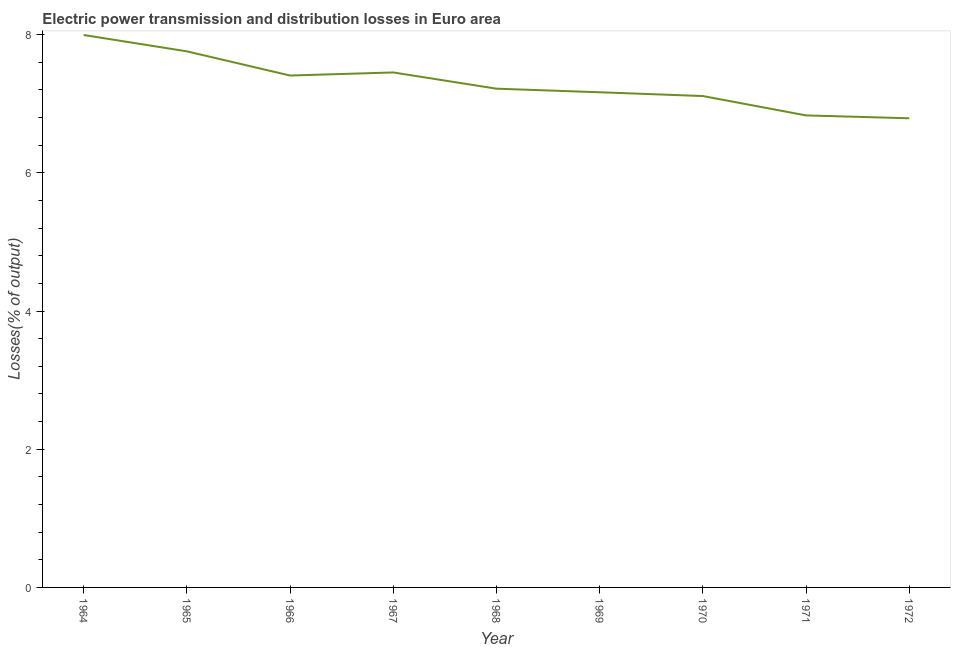What is the electric power transmission and distribution losses in 1965?
Make the answer very short. 7.76. Across all years, what is the maximum electric power transmission and distribution losses?
Offer a terse response. 8. Across all years, what is the minimum electric power transmission and distribution losses?
Give a very brief answer. 6.79. In which year was the electric power transmission and distribution losses maximum?
Ensure brevity in your answer.  1964. In which year was the electric power transmission and distribution losses minimum?
Your answer should be very brief. 1972. What is the sum of the electric power transmission and distribution losses?
Ensure brevity in your answer.  65.74. What is the difference between the electric power transmission and distribution losses in 1968 and 1971?
Give a very brief answer. 0.39. What is the average electric power transmission and distribution losses per year?
Provide a short and direct response. 7.3. What is the median electric power transmission and distribution losses?
Ensure brevity in your answer.  7.22. In how many years, is the electric power transmission and distribution losses greater than 2.8 %?
Offer a terse response. 9. Do a majority of the years between 1970 and 1965 (inclusive) have electric power transmission and distribution losses greater than 3.2 %?
Offer a very short reply. Yes. What is the ratio of the electric power transmission and distribution losses in 1966 to that in 1970?
Keep it short and to the point. 1.04. Is the electric power transmission and distribution losses in 1966 less than that in 1967?
Offer a very short reply. Yes. What is the difference between the highest and the second highest electric power transmission and distribution losses?
Provide a short and direct response. 0.24. What is the difference between the highest and the lowest electric power transmission and distribution losses?
Provide a short and direct response. 1.21. Does the electric power transmission and distribution losses monotonically increase over the years?
Your answer should be very brief. No. How many years are there in the graph?
Make the answer very short. 9. What is the difference between two consecutive major ticks on the Y-axis?
Provide a succinct answer. 2. Are the values on the major ticks of Y-axis written in scientific E-notation?
Offer a terse response. No. Does the graph contain any zero values?
Ensure brevity in your answer.  No. Does the graph contain grids?
Provide a short and direct response. No. What is the title of the graph?
Provide a succinct answer. Electric power transmission and distribution losses in Euro area. What is the label or title of the Y-axis?
Offer a terse response. Losses(% of output). What is the Losses(% of output) in 1964?
Give a very brief answer. 8. What is the Losses(% of output) of 1965?
Keep it short and to the point. 7.76. What is the Losses(% of output) of 1966?
Your response must be concise. 7.41. What is the Losses(% of output) in 1967?
Ensure brevity in your answer.  7.45. What is the Losses(% of output) in 1968?
Keep it short and to the point. 7.22. What is the Losses(% of output) of 1969?
Your answer should be compact. 7.17. What is the Losses(% of output) of 1970?
Your answer should be very brief. 7.11. What is the Losses(% of output) in 1971?
Your answer should be compact. 6.83. What is the Losses(% of output) of 1972?
Provide a short and direct response. 6.79. What is the difference between the Losses(% of output) in 1964 and 1965?
Make the answer very short. 0.24. What is the difference between the Losses(% of output) in 1964 and 1966?
Your response must be concise. 0.59. What is the difference between the Losses(% of output) in 1964 and 1967?
Ensure brevity in your answer.  0.54. What is the difference between the Losses(% of output) in 1964 and 1968?
Provide a succinct answer. 0.78. What is the difference between the Losses(% of output) in 1964 and 1969?
Your answer should be compact. 0.83. What is the difference between the Losses(% of output) in 1964 and 1970?
Offer a very short reply. 0.88. What is the difference between the Losses(% of output) in 1964 and 1971?
Make the answer very short. 1.16. What is the difference between the Losses(% of output) in 1964 and 1972?
Provide a short and direct response. 1.21. What is the difference between the Losses(% of output) in 1965 and 1966?
Your response must be concise. 0.35. What is the difference between the Losses(% of output) in 1965 and 1967?
Make the answer very short. 0.31. What is the difference between the Losses(% of output) in 1965 and 1968?
Give a very brief answer. 0.54. What is the difference between the Losses(% of output) in 1965 and 1969?
Make the answer very short. 0.59. What is the difference between the Losses(% of output) in 1965 and 1970?
Ensure brevity in your answer.  0.65. What is the difference between the Losses(% of output) in 1965 and 1971?
Offer a very short reply. 0.93. What is the difference between the Losses(% of output) in 1965 and 1972?
Provide a short and direct response. 0.97. What is the difference between the Losses(% of output) in 1966 and 1967?
Your answer should be very brief. -0.04. What is the difference between the Losses(% of output) in 1966 and 1968?
Provide a short and direct response. 0.19. What is the difference between the Losses(% of output) in 1966 and 1969?
Your answer should be compact. 0.24. What is the difference between the Losses(% of output) in 1966 and 1970?
Provide a succinct answer. 0.3. What is the difference between the Losses(% of output) in 1966 and 1971?
Your response must be concise. 0.58. What is the difference between the Losses(% of output) in 1966 and 1972?
Offer a terse response. 0.62. What is the difference between the Losses(% of output) in 1967 and 1968?
Ensure brevity in your answer.  0.23. What is the difference between the Losses(% of output) in 1967 and 1969?
Your response must be concise. 0.29. What is the difference between the Losses(% of output) in 1967 and 1970?
Offer a very short reply. 0.34. What is the difference between the Losses(% of output) in 1967 and 1971?
Provide a succinct answer. 0.62. What is the difference between the Losses(% of output) in 1967 and 1972?
Provide a short and direct response. 0.66. What is the difference between the Losses(% of output) in 1968 and 1969?
Ensure brevity in your answer.  0.05. What is the difference between the Losses(% of output) in 1968 and 1970?
Make the answer very short. 0.11. What is the difference between the Losses(% of output) in 1968 and 1971?
Your response must be concise. 0.39. What is the difference between the Losses(% of output) in 1968 and 1972?
Your answer should be compact. 0.43. What is the difference between the Losses(% of output) in 1969 and 1970?
Provide a short and direct response. 0.05. What is the difference between the Losses(% of output) in 1969 and 1971?
Make the answer very short. 0.33. What is the difference between the Losses(% of output) in 1969 and 1972?
Provide a short and direct response. 0.38. What is the difference between the Losses(% of output) in 1970 and 1971?
Your response must be concise. 0.28. What is the difference between the Losses(% of output) in 1970 and 1972?
Make the answer very short. 0.32. What is the difference between the Losses(% of output) in 1971 and 1972?
Offer a very short reply. 0.04. What is the ratio of the Losses(% of output) in 1964 to that in 1965?
Offer a very short reply. 1.03. What is the ratio of the Losses(% of output) in 1964 to that in 1966?
Your answer should be very brief. 1.08. What is the ratio of the Losses(% of output) in 1964 to that in 1967?
Ensure brevity in your answer.  1.07. What is the ratio of the Losses(% of output) in 1964 to that in 1968?
Keep it short and to the point. 1.11. What is the ratio of the Losses(% of output) in 1964 to that in 1969?
Offer a terse response. 1.12. What is the ratio of the Losses(% of output) in 1964 to that in 1970?
Provide a short and direct response. 1.12. What is the ratio of the Losses(% of output) in 1964 to that in 1971?
Offer a terse response. 1.17. What is the ratio of the Losses(% of output) in 1964 to that in 1972?
Your answer should be compact. 1.18. What is the ratio of the Losses(% of output) in 1965 to that in 1966?
Offer a very short reply. 1.05. What is the ratio of the Losses(% of output) in 1965 to that in 1967?
Your response must be concise. 1.04. What is the ratio of the Losses(% of output) in 1965 to that in 1968?
Provide a succinct answer. 1.07. What is the ratio of the Losses(% of output) in 1965 to that in 1969?
Keep it short and to the point. 1.08. What is the ratio of the Losses(% of output) in 1965 to that in 1970?
Offer a terse response. 1.09. What is the ratio of the Losses(% of output) in 1965 to that in 1971?
Give a very brief answer. 1.14. What is the ratio of the Losses(% of output) in 1965 to that in 1972?
Provide a succinct answer. 1.14. What is the ratio of the Losses(% of output) in 1966 to that in 1969?
Keep it short and to the point. 1.03. What is the ratio of the Losses(% of output) in 1966 to that in 1970?
Offer a very short reply. 1.04. What is the ratio of the Losses(% of output) in 1966 to that in 1971?
Your answer should be compact. 1.08. What is the ratio of the Losses(% of output) in 1966 to that in 1972?
Your response must be concise. 1.09. What is the ratio of the Losses(% of output) in 1967 to that in 1968?
Offer a terse response. 1.03. What is the ratio of the Losses(% of output) in 1967 to that in 1969?
Keep it short and to the point. 1.04. What is the ratio of the Losses(% of output) in 1967 to that in 1970?
Keep it short and to the point. 1.05. What is the ratio of the Losses(% of output) in 1967 to that in 1971?
Your answer should be compact. 1.09. What is the ratio of the Losses(% of output) in 1967 to that in 1972?
Make the answer very short. 1.1. What is the ratio of the Losses(% of output) in 1968 to that in 1969?
Your answer should be compact. 1.01. What is the ratio of the Losses(% of output) in 1968 to that in 1971?
Your answer should be compact. 1.06. What is the ratio of the Losses(% of output) in 1968 to that in 1972?
Keep it short and to the point. 1.06. What is the ratio of the Losses(% of output) in 1969 to that in 1970?
Give a very brief answer. 1.01. What is the ratio of the Losses(% of output) in 1969 to that in 1971?
Provide a succinct answer. 1.05. What is the ratio of the Losses(% of output) in 1969 to that in 1972?
Ensure brevity in your answer.  1.05. What is the ratio of the Losses(% of output) in 1970 to that in 1971?
Make the answer very short. 1.04. What is the ratio of the Losses(% of output) in 1970 to that in 1972?
Ensure brevity in your answer.  1.05. What is the ratio of the Losses(% of output) in 1971 to that in 1972?
Offer a very short reply. 1.01. 